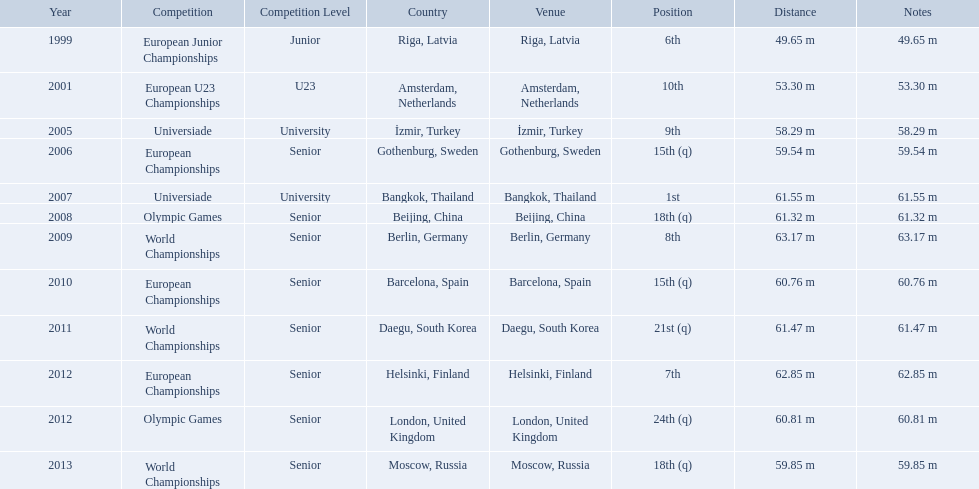What were the distances of mayer's throws? 49.65 m, 53.30 m, 58.29 m, 59.54 m, 61.55 m, 61.32 m, 63.17 m, 60.76 m, 61.47 m, 62.85 m, 60.81 m, 59.85 m. Which of these went the farthest? 63.17 m. Which competitions has gerhard mayer competed in since 1999? European Junior Championships, European U23 Championships, Universiade, European Championships, Universiade, Olympic Games, World Championships, European Championships, World Championships, European Championships, Olympic Games, World Championships. Of these competition, in which ones did he throw at least 60 m? Universiade, Olympic Games, World Championships, European Championships, World Championships, European Championships, Olympic Games. Of these throws, which was his longest? 63.17 m. 